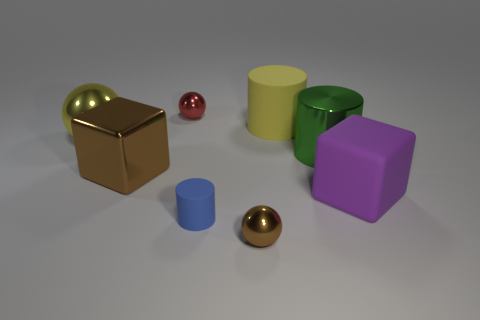There is a tiny metallic object that is the same color as the shiny block; what is its shape?
Provide a succinct answer. Sphere. There is a object that is in front of the blue matte cylinder; does it have the same color as the large block on the left side of the red metal ball?
Provide a succinct answer. Yes. How many other objects are there of the same material as the red ball?
Your answer should be compact. 4. The rubber object that is both to the left of the green cylinder and in front of the big matte cylinder has what shape?
Give a very brief answer. Cylinder. Does the big rubber cylinder have the same color as the shiny sphere that is to the left of the brown metallic block?
Give a very brief answer. Yes. Do the ball that is behind the yellow metallic object and the tiny rubber object have the same size?
Keep it short and to the point. Yes. There is another small object that is the same shape as the green object; what is its material?
Give a very brief answer. Rubber. Does the small red metal object have the same shape as the large yellow metal thing?
Give a very brief answer. Yes. There is a block to the left of the brown shiny ball; what number of tiny blue matte objects are in front of it?
Offer a terse response. 1. What is the shape of the large yellow thing that is the same material as the red thing?
Your response must be concise. Sphere. 